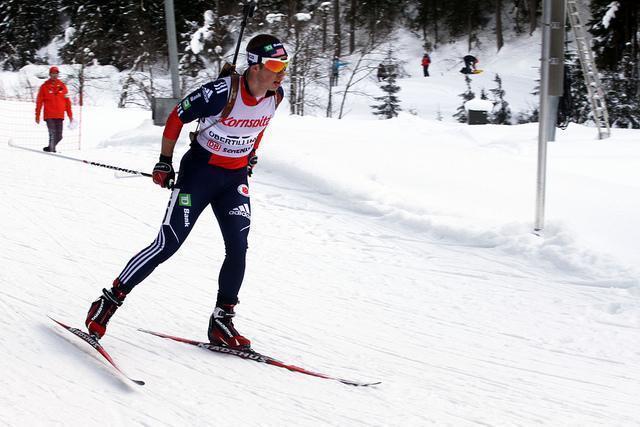What is required for this activity?
From the following set of four choices, select the accurate answer to respond to the question.
Options: Sun, snow, wind, water. Snow. 